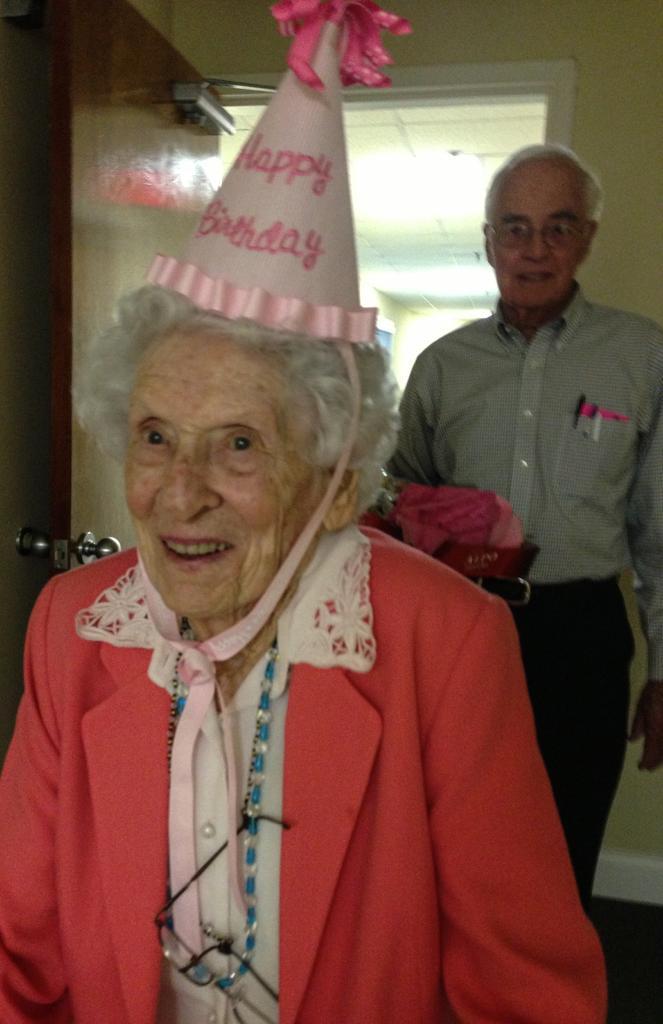How would you summarize this image in a sentence or two? In this image I can see two people with different color dresses and one person with the birthday-cap. In the background I can see the door and the ceiling at the top. 